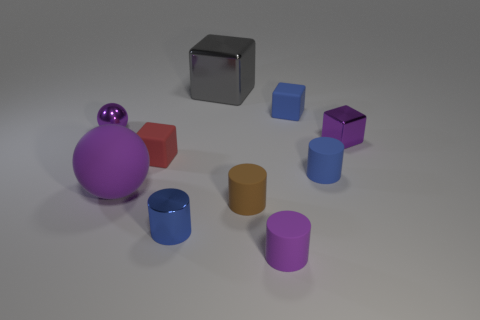Subtract all cyan cylinders. Subtract all green balls. How many cylinders are left? 4 Subtract all cylinders. How many objects are left? 6 Add 7 tiny purple metal blocks. How many tiny purple metal blocks are left? 8 Add 1 big matte balls. How many big matte balls exist? 2 Subtract 0 red cylinders. How many objects are left? 10 Subtract all small gray things. Subtract all big purple rubber things. How many objects are left? 9 